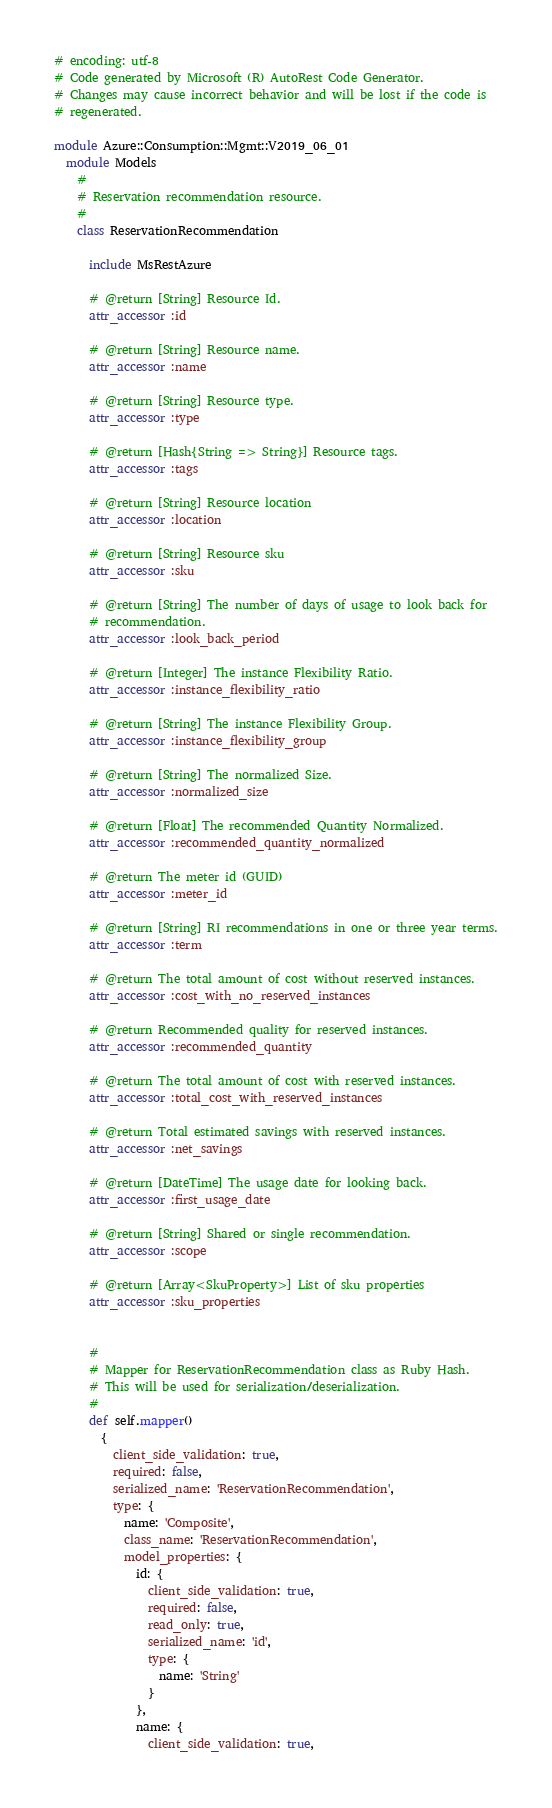Convert code to text. <code><loc_0><loc_0><loc_500><loc_500><_Ruby_># encoding: utf-8
# Code generated by Microsoft (R) AutoRest Code Generator.
# Changes may cause incorrect behavior and will be lost if the code is
# regenerated.

module Azure::Consumption::Mgmt::V2019_06_01
  module Models
    #
    # Reservation recommendation resource.
    #
    class ReservationRecommendation

      include MsRestAzure

      # @return [String] Resource Id.
      attr_accessor :id

      # @return [String] Resource name.
      attr_accessor :name

      # @return [String] Resource type.
      attr_accessor :type

      # @return [Hash{String => String}] Resource tags.
      attr_accessor :tags

      # @return [String] Resource location
      attr_accessor :location

      # @return [String] Resource sku
      attr_accessor :sku

      # @return [String] The number of days of usage to look back for
      # recommendation.
      attr_accessor :look_back_period

      # @return [Integer] The instance Flexibility Ratio.
      attr_accessor :instance_flexibility_ratio

      # @return [String] The instance Flexibility Group.
      attr_accessor :instance_flexibility_group

      # @return [String] The normalized Size.
      attr_accessor :normalized_size

      # @return [Float] The recommended Quantity Normalized.
      attr_accessor :recommended_quantity_normalized

      # @return The meter id (GUID)
      attr_accessor :meter_id

      # @return [String] RI recommendations in one or three year terms.
      attr_accessor :term

      # @return The total amount of cost without reserved instances.
      attr_accessor :cost_with_no_reserved_instances

      # @return Recommended quality for reserved instances.
      attr_accessor :recommended_quantity

      # @return The total amount of cost with reserved instances.
      attr_accessor :total_cost_with_reserved_instances

      # @return Total estimated savings with reserved instances.
      attr_accessor :net_savings

      # @return [DateTime] The usage date for looking back.
      attr_accessor :first_usage_date

      # @return [String] Shared or single recommendation.
      attr_accessor :scope

      # @return [Array<SkuProperty>] List of sku properties
      attr_accessor :sku_properties


      #
      # Mapper for ReservationRecommendation class as Ruby Hash.
      # This will be used for serialization/deserialization.
      #
      def self.mapper()
        {
          client_side_validation: true,
          required: false,
          serialized_name: 'ReservationRecommendation',
          type: {
            name: 'Composite',
            class_name: 'ReservationRecommendation',
            model_properties: {
              id: {
                client_side_validation: true,
                required: false,
                read_only: true,
                serialized_name: 'id',
                type: {
                  name: 'String'
                }
              },
              name: {
                client_side_validation: true,</code> 